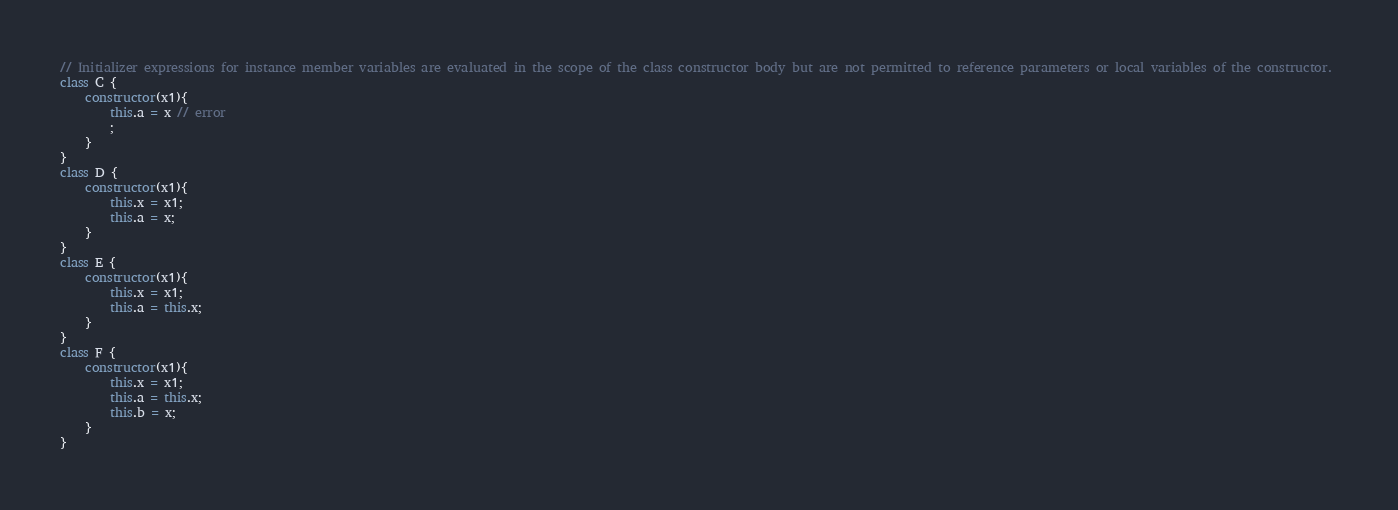<code> <loc_0><loc_0><loc_500><loc_500><_JavaScript_>// Initializer expressions for instance member variables are evaluated in the scope of the class constructor body but are not permitted to reference parameters or local variables of the constructor. 
class C {
    constructor(x1){
        this.a = x // error
        ;
    }
}
class D {
    constructor(x1){
        this.x = x1;
        this.a = x;
    }
}
class E {
    constructor(x1){
        this.x = x1;
        this.a = this.x;
    }
}
class F {
    constructor(x1){
        this.x = x1;
        this.a = this.x;
        this.b = x;
    }
}
</code> 